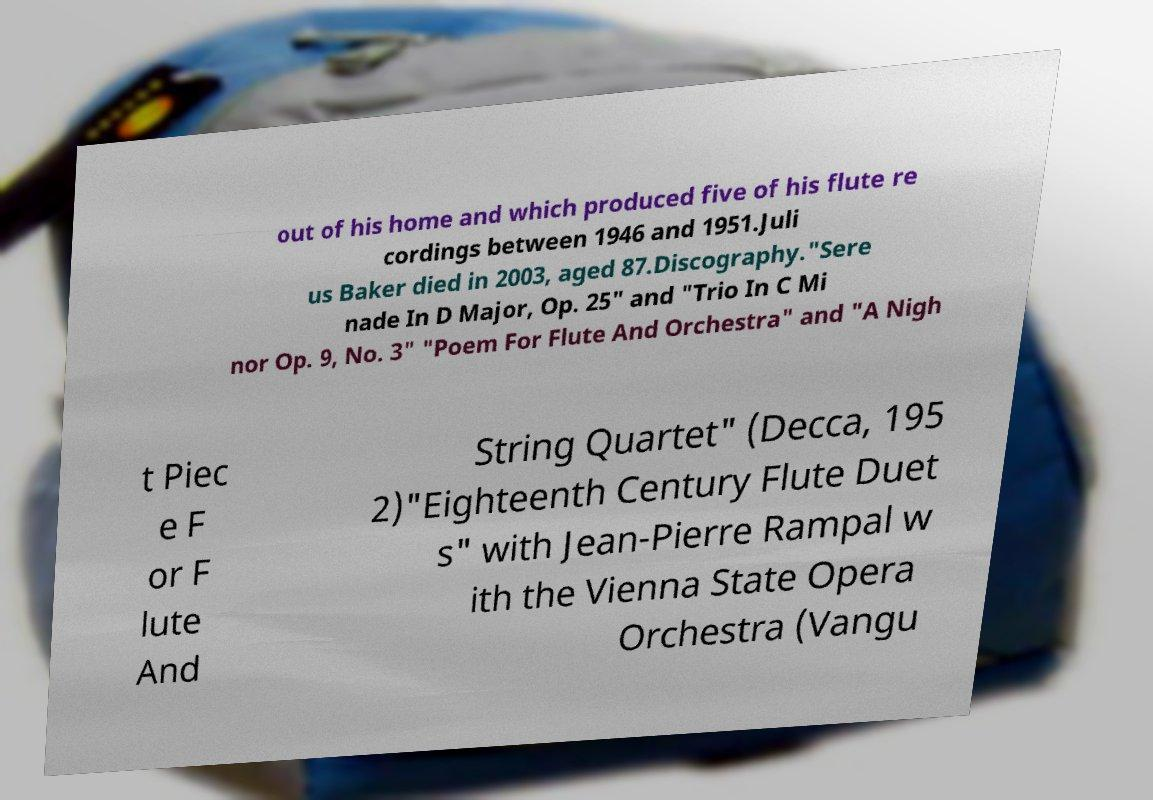For documentation purposes, I need the text within this image transcribed. Could you provide that? out of his home and which produced five of his flute re cordings between 1946 and 1951.Juli us Baker died in 2003, aged 87.Discography."Sere nade In D Major, Op. 25" and "Trio In C Mi nor Op. 9, No. 3" "Poem For Flute And Orchestra" and "A Nigh t Piec e F or F lute And String Quartet" (Decca, 195 2)"Eighteenth Century Flute Duet s" with Jean-Pierre Rampal w ith the Vienna State Opera Orchestra (Vangu 